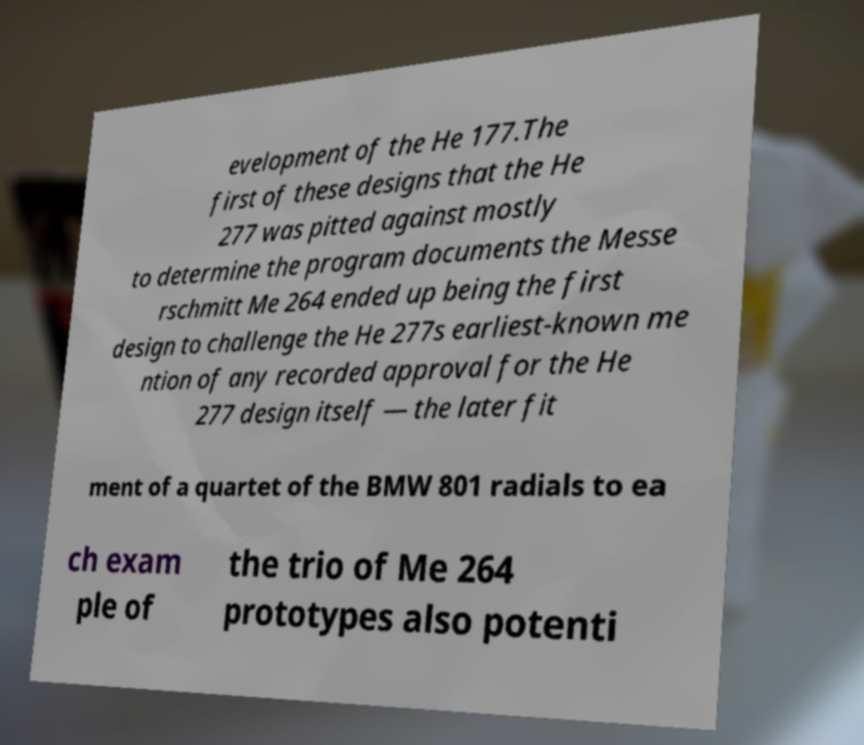There's text embedded in this image that I need extracted. Can you transcribe it verbatim? evelopment of the He 177.The first of these designs that the He 277 was pitted against mostly to determine the program documents the Messe rschmitt Me 264 ended up being the first design to challenge the He 277s earliest-known me ntion of any recorded approval for the He 277 design itself — the later fit ment of a quartet of the BMW 801 radials to ea ch exam ple of the trio of Me 264 prototypes also potenti 